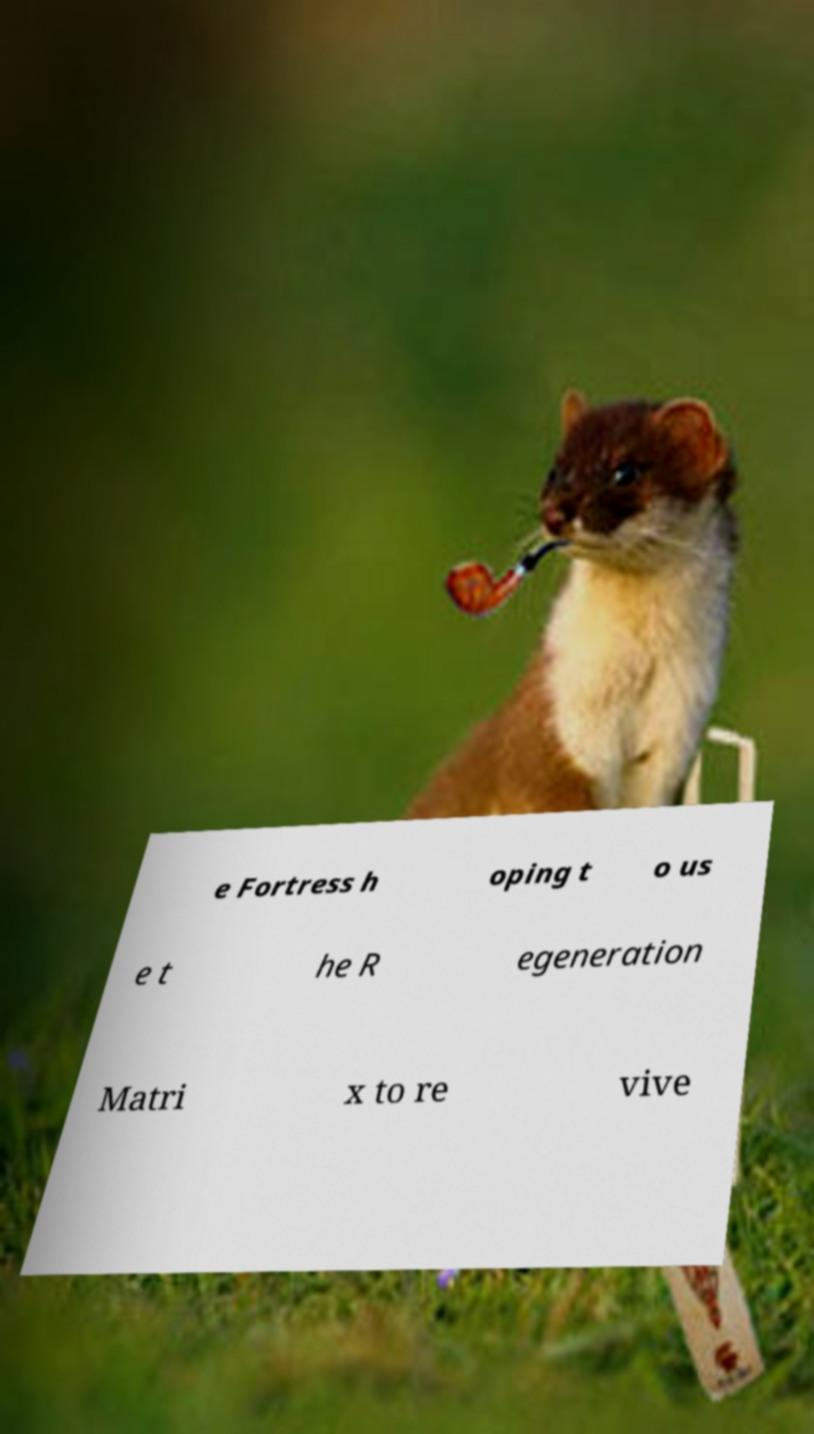For documentation purposes, I need the text within this image transcribed. Could you provide that? e Fortress h oping t o us e t he R egeneration Matri x to re vive 